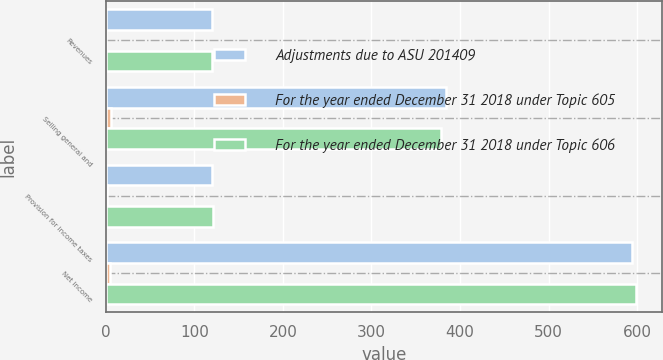Convert chart to OTSL. <chart><loc_0><loc_0><loc_500><loc_500><stacked_bar_chart><ecel><fcel>Revenues<fcel>Selling general and<fcel>Provision for income taxes<fcel>Net income<nl><fcel>Adjustments due to ASU 201409<fcel>120.25<fcel>384<fcel>119.5<fcel>594.2<nl><fcel>For the year ended December 31 2018 under Topic 605<fcel>0.7<fcel>5.3<fcel>1.5<fcel>4.5<nl><fcel>For the year ended December 31 2018 under Topic 606<fcel>120.25<fcel>378.7<fcel>121<fcel>598.7<nl></chart> 